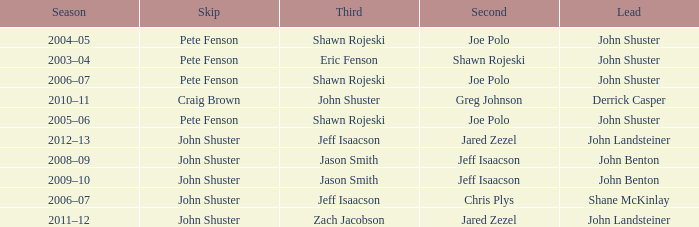Who was the lead with Pete Fenson as skip and Joe Polo as second in season 2005–06? John Shuster. 